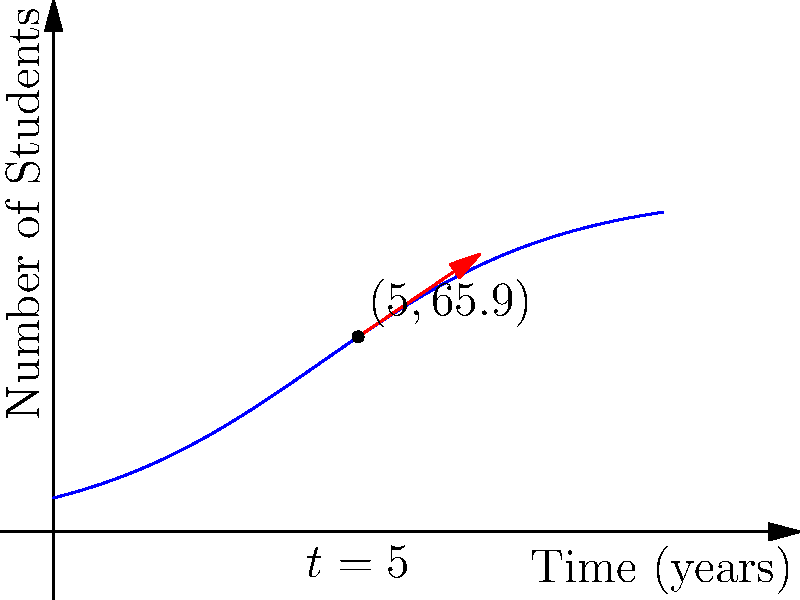Your English language academy's growth can be modeled by the function $N(t) = \frac{100}{1+9e^{-0.5t}}$, where $N$ is the number of students and $t$ is time in years. Using the tangent line at $t=5$ years, estimate the number of new students you can expect to enroll in the next year. Round your answer to the nearest whole number. To solve this problem, we'll follow these steps:

1) First, we need to find the value of $N(5)$:
   $N(5) = \frac{100}{1+9e^{-0.5(5)}} \approx 65.9$ students

2) Now, we need to find the slope of the tangent line at $t=5$. This is given by the derivative of $N(t)$ at $t=5$:
   $N'(t) = \frac{100 \cdot 9 \cdot 0.5e^{-0.5t}}{(1+9e^{-0.5t})^2}$
   $N'(5) \approx 11.3$ students/year

3) The tangent line represents the rate of change at that point. So, in one year, we can expect an increase of approximately 11.3 students.

4) Rounding to the nearest whole number, we get 11 new students expected in the next year.
Answer: 11 new students 